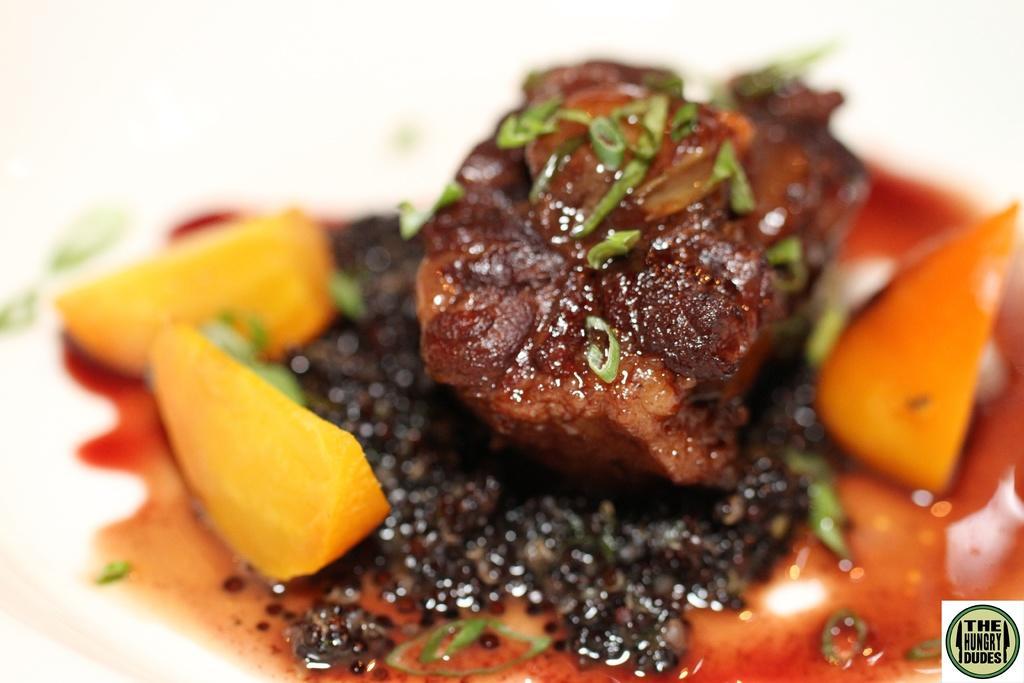How would you summarize this image in a sentence or two? This is the picture of some food item which is in brown, orange and yellow color and there are some green color things on it. 